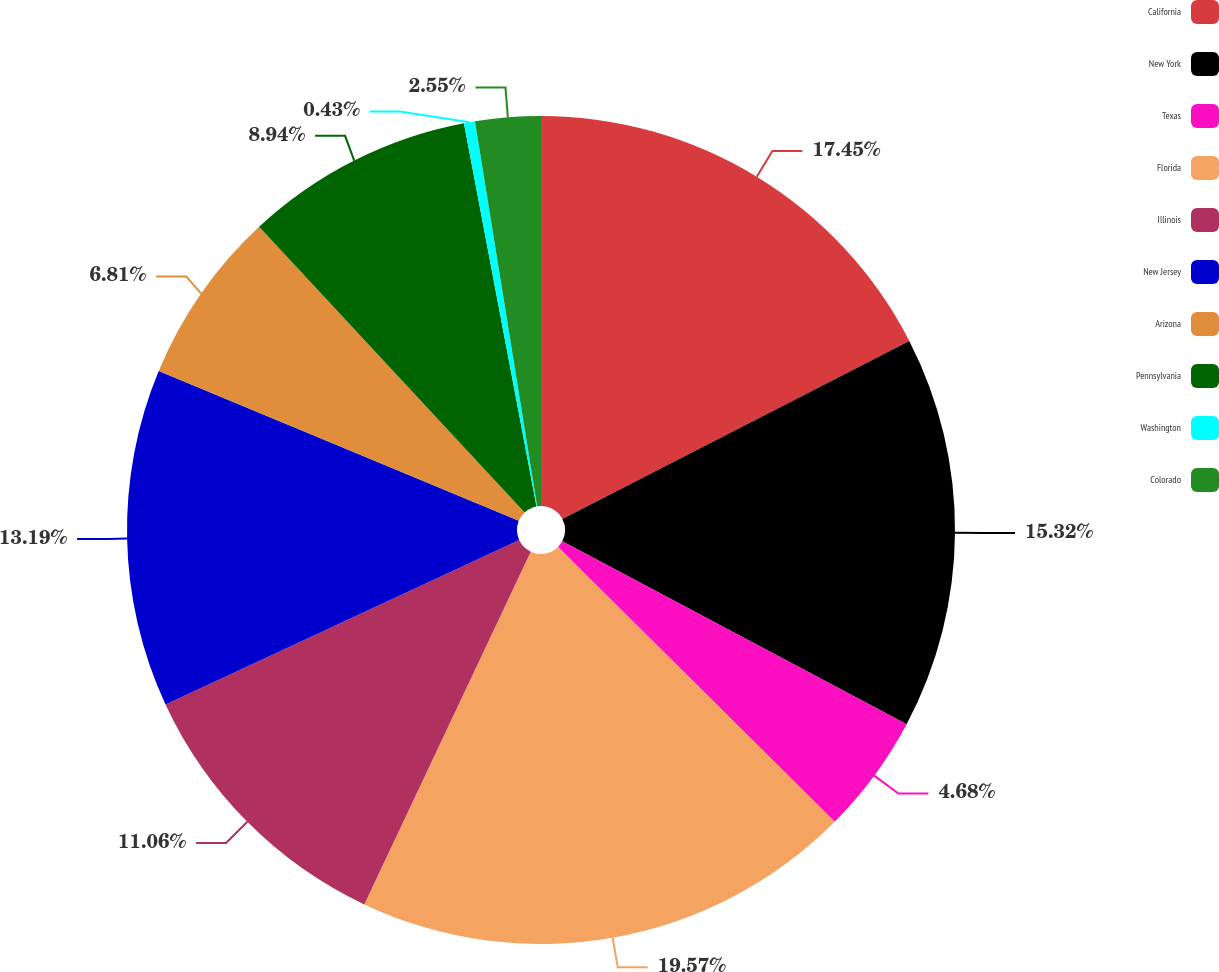<chart> <loc_0><loc_0><loc_500><loc_500><pie_chart><fcel>California<fcel>New York<fcel>Texas<fcel>Florida<fcel>Illinois<fcel>New Jersey<fcel>Arizona<fcel>Pennsylvania<fcel>Washington<fcel>Colorado<nl><fcel>17.45%<fcel>15.32%<fcel>4.68%<fcel>19.57%<fcel>11.06%<fcel>13.19%<fcel>6.81%<fcel>8.94%<fcel>0.43%<fcel>2.55%<nl></chart> 